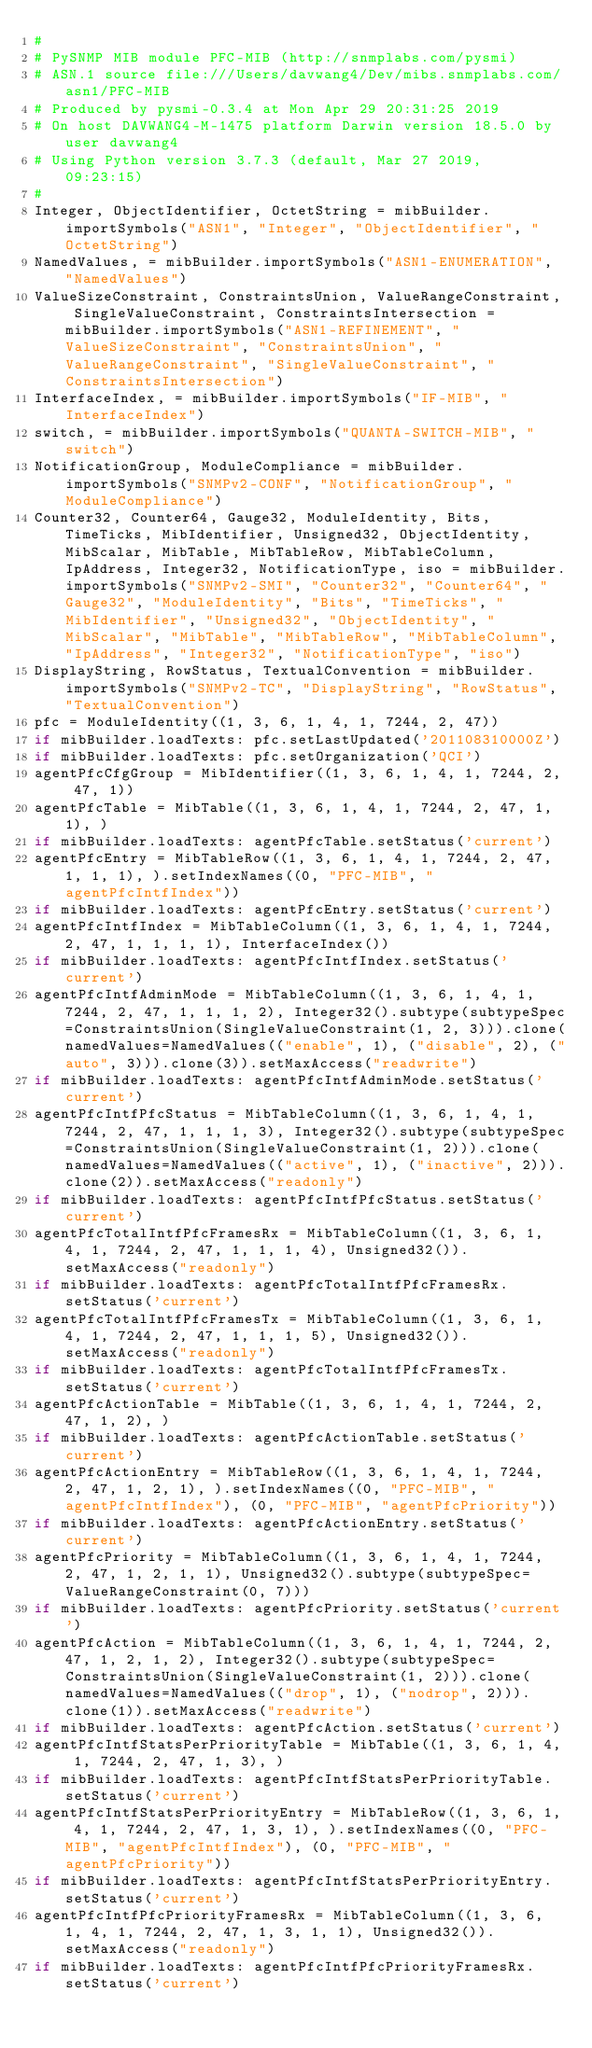<code> <loc_0><loc_0><loc_500><loc_500><_Python_>#
# PySNMP MIB module PFC-MIB (http://snmplabs.com/pysmi)
# ASN.1 source file:///Users/davwang4/Dev/mibs.snmplabs.com/asn1/PFC-MIB
# Produced by pysmi-0.3.4 at Mon Apr 29 20:31:25 2019
# On host DAVWANG4-M-1475 platform Darwin version 18.5.0 by user davwang4
# Using Python version 3.7.3 (default, Mar 27 2019, 09:23:15) 
#
Integer, ObjectIdentifier, OctetString = mibBuilder.importSymbols("ASN1", "Integer", "ObjectIdentifier", "OctetString")
NamedValues, = mibBuilder.importSymbols("ASN1-ENUMERATION", "NamedValues")
ValueSizeConstraint, ConstraintsUnion, ValueRangeConstraint, SingleValueConstraint, ConstraintsIntersection = mibBuilder.importSymbols("ASN1-REFINEMENT", "ValueSizeConstraint", "ConstraintsUnion", "ValueRangeConstraint", "SingleValueConstraint", "ConstraintsIntersection")
InterfaceIndex, = mibBuilder.importSymbols("IF-MIB", "InterfaceIndex")
switch, = mibBuilder.importSymbols("QUANTA-SWITCH-MIB", "switch")
NotificationGroup, ModuleCompliance = mibBuilder.importSymbols("SNMPv2-CONF", "NotificationGroup", "ModuleCompliance")
Counter32, Counter64, Gauge32, ModuleIdentity, Bits, TimeTicks, MibIdentifier, Unsigned32, ObjectIdentity, MibScalar, MibTable, MibTableRow, MibTableColumn, IpAddress, Integer32, NotificationType, iso = mibBuilder.importSymbols("SNMPv2-SMI", "Counter32", "Counter64", "Gauge32", "ModuleIdentity", "Bits", "TimeTicks", "MibIdentifier", "Unsigned32", "ObjectIdentity", "MibScalar", "MibTable", "MibTableRow", "MibTableColumn", "IpAddress", "Integer32", "NotificationType", "iso")
DisplayString, RowStatus, TextualConvention = mibBuilder.importSymbols("SNMPv2-TC", "DisplayString", "RowStatus", "TextualConvention")
pfc = ModuleIdentity((1, 3, 6, 1, 4, 1, 7244, 2, 47))
if mibBuilder.loadTexts: pfc.setLastUpdated('201108310000Z')
if mibBuilder.loadTexts: pfc.setOrganization('QCI')
agentPfcCfgGroup = MibIdentifier((1, 3, 6, 1, 4, 1, 7244, 2, 47, 1))
agentPfcTable = MibTable((1, 3, 6, 1, 4, 1, 7244, 2, 47, 1, 1), )
if mibBuilder.loadTexts: agentPfcTable.setStatus('current')
agentPfcEntry = MibTableRow((1, 3, 6, 1, 4, 1, 7244, 2, 47, 1, 1, 1), ).setIndexNames((0, "PFC-MIB", "agentPfcIntfIndex"))
if mibBuilder.loadTexts: agentPfcEntry.setStatus('current')
agentPfcIntfIndex = MibTableColumn((1, 3, 6, 1, 4, 1, 7244, 2, 47, 1, 1, 1, 1), InterfaceIndex())
if mibBuilder.loadTexts: agentPfcIntfIndex.setStatus('current')
agentPfcIntfAdminMode = MibTableColumn((1, 3, 6, 1, 4, 1, 7244, 2, 47, 1, 1, 1, 2), Integer32().subtype(subtypeSpec=ConstraintsUnion(SingleValueConstraint(1, 2, 3))).clone(namedValues=NamedValues(("enable", 1), ("disable", 2), ("auto", 3))).clone(3)).setMaxAccess("readwrite")
if mibBuilder.loadTexts: agentPfcIntfAdminMode.setStatus('current')
agentPfcIntfPfcStatus = MibTableColumn((1, 3, 6, 1, 4, 1, 7244, 2, 47, 1, 1, 1, 3), Integer32().subtype(subtypeSpec=ConstraintsUnion(SingleValueConstraint(1, 2))).clone(namedValues=NamedValues(("active", 1), ("inactive", 2))).clone(2)).setMaxAccess("readonly")
if mibBuilder.loadTexts: agentPfcIntfPfcStatus.setStatus('current')
agentPfcTotalIntfPfcFramesRx = MibTableColumn((1, 3, 6, 1, 4, 1, 7244, 2, 47, 1, 1, 1, 4), Unsigned32()).setMaxAccess("readonly")
if mibBuilder.loadTexts: agentPfcTotalIntfPfcFramesRx.setStatus('current')
agentPfcTotalIntfPfcFramesTx = MibTableColumn((1, 3, 6, 1, 4, 1, 7244, 2, 47, 1, 1, 1, 5), Unsigned32()).setMaxAccess("readonly")
if mibBuilder.loadTexts: agentPfcTotalIntfPfcFramesTx.setStatus('current')
agentPfcActionTable = MibTable((1, 3, 6, 1, 4, 1, 7244, 2, 47, 1, 2), )
if mibBuilder.loadTexts: agentPfcActionTable.setStatus('current')
agentPfcActionEntry = MibTableRow((1, 3, 6, 1, 4, 1, 7244, 2, 47, 1, 2, 1), ).setIndexNames((0, "PFC-MIB", "agentPfcIntfIndex"), (0, "PFC-MIB", "agentPfcPriority"))
if mibBuilder.loadTexts: agentPfcActionEntry.setStatus('current')
agentPfcPriority = MibTableColumn((1, 3, 6, 1, 4, 1, 7244, 2, 47, 1, 2, 1, 1), Unsigned32().subtype(subtypeSpec=ValueRangeConstraint(0, 7)))
if mibBuilder.loadTexts: agentPfcPriority.setStatus('current')
agentPfcAction = MibTableColumn((1, 3, 6, 1, 4, 1, 7244, 2, 47, 1, 2, 1, 2), Integer32().subtype(subtypeSpec=ConstraintsUnion(SingleValueConstraint(1, 2))).clone(namedValues=NamedValues(("drop", 1), ("nodrop", 2))).clone(1)).setMaxAccess("readwrite")
if mibBuilder.loadTexts: agentPfcAction.setStatus('current')
agentPfcIntfStatsPerPriorityTable = MibTable((1, 3, 6, 1, 4, 1, 7244, 2, 47, 1, 3), )
if mibBuilder.loadTexts: agentPfcIntfStatsPerPriorityTable.setStatus('current')
agentPfcIntfStatsPerPriorityEntry = MibTableRow((1, 3, 6, 1, 4, 1, 7244, 2, 47, 1, 3, 1), ).setIndexNames((0, "PFC-MIB", "agentPfcIntfIndex"), (0, "PFC-MIB", "agentPfcPriority"))
if mibBuilder.loadTexts: agentPfcIntfStatsPerPriorityEntry.setStatus('current')
agentPfcIntfPfcPriorityFramesRx = MibTableColumn((1, 3, 6, 1, 4, 1, 7244, 2, 47, 1, 3, 1, 1), Unsigned32()).setMaxAccess("readonly")
if mibBuilder.loadTexts: agentPfcIntfPfcPriorityFramesRx.setStatus('current')</code> 